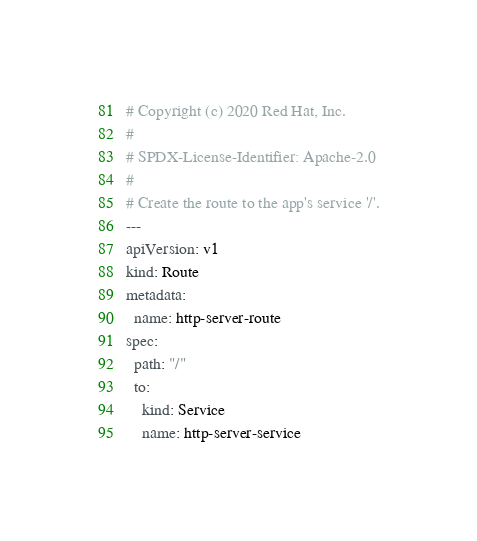Convert code to text. <code><loc_0><loc_0><loc_500><loc_500><_YAML_># Copyright (c) 2020 Red Hat, Inc.
#
# SPDX-License-Identifier: Apache-2.0
#
# Create the route to the app's service '/'.
---
apiVersion: v1
kind: Route
metadata:
  name: http-server-route
spec:
  path: "/" 
  to:
    kind: Service
    name: http-server-service
</code> 